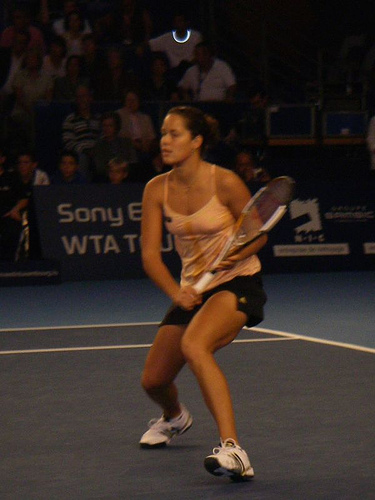<image>What kind of computers are advertised? I am not sure what kind of computers are advertised. It could be Sony. What kind of computers are advertised? I don't know what kind of computers are advertised. It can be Sony computers. 